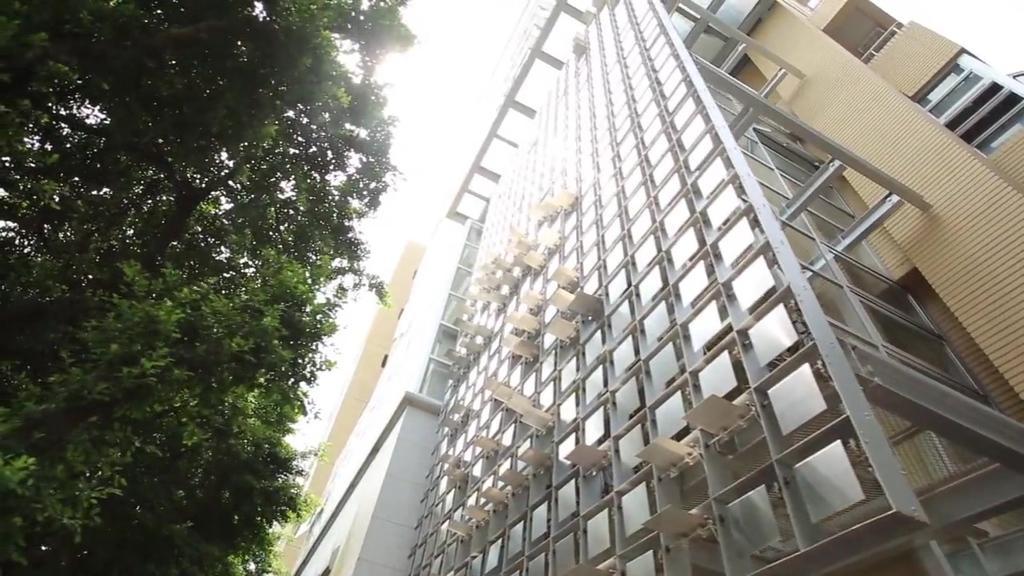Could you give a brief overview of what you see in this image? In this picture there is a building. On the left side of the image there is a tree. At the top there is sky. 